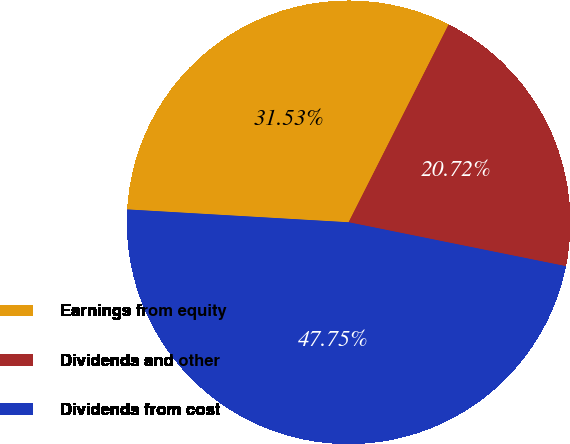<chart> <loc_0><loc_0><loc_500><loc_500><pie_chart><fcel>Earnings from equity<fcel>Dividends and other<fcel>Dividends from cost<nl><fcel>31.53%<fcel>20.72%<fcel>47.75%<nl></chart> 